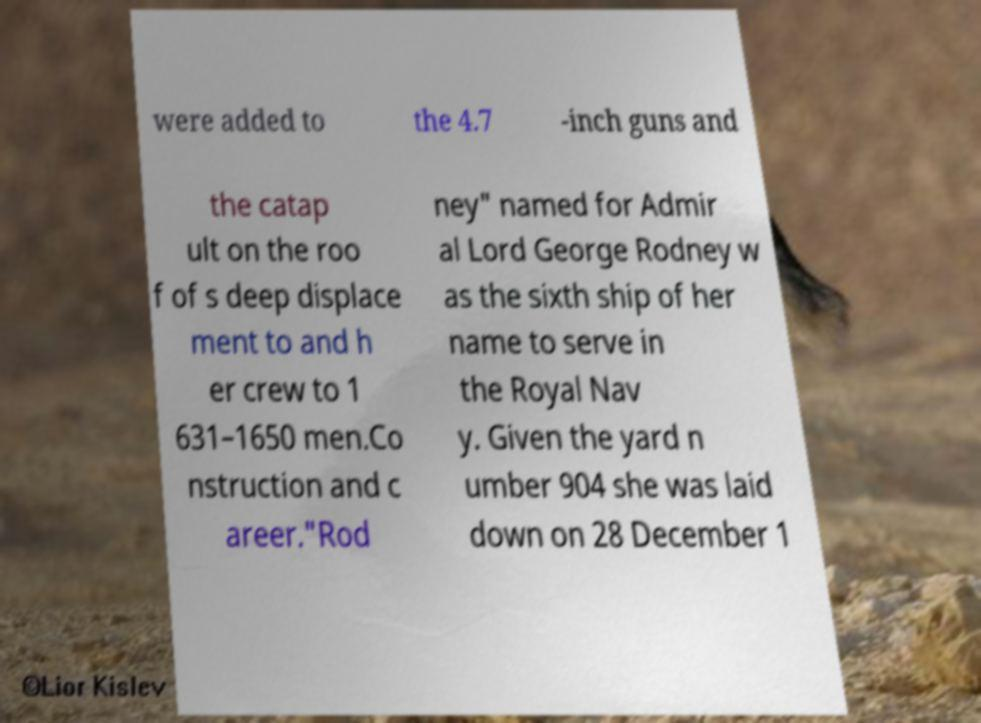Could you assist in decoding the text presented in this image and type it out clearly? were added to the 4.7 -inch guns and the catap ult on the roo f of s deep displace ment to and h er crew to 1 631–1650 men.Co nstruction and c areer."Rod ney" named for Admir al Lord George Rodney w as the sixth ship of her name to serve in the Royal Nav y. Given the yard n umber 904 she was laid down on 28 December 1 